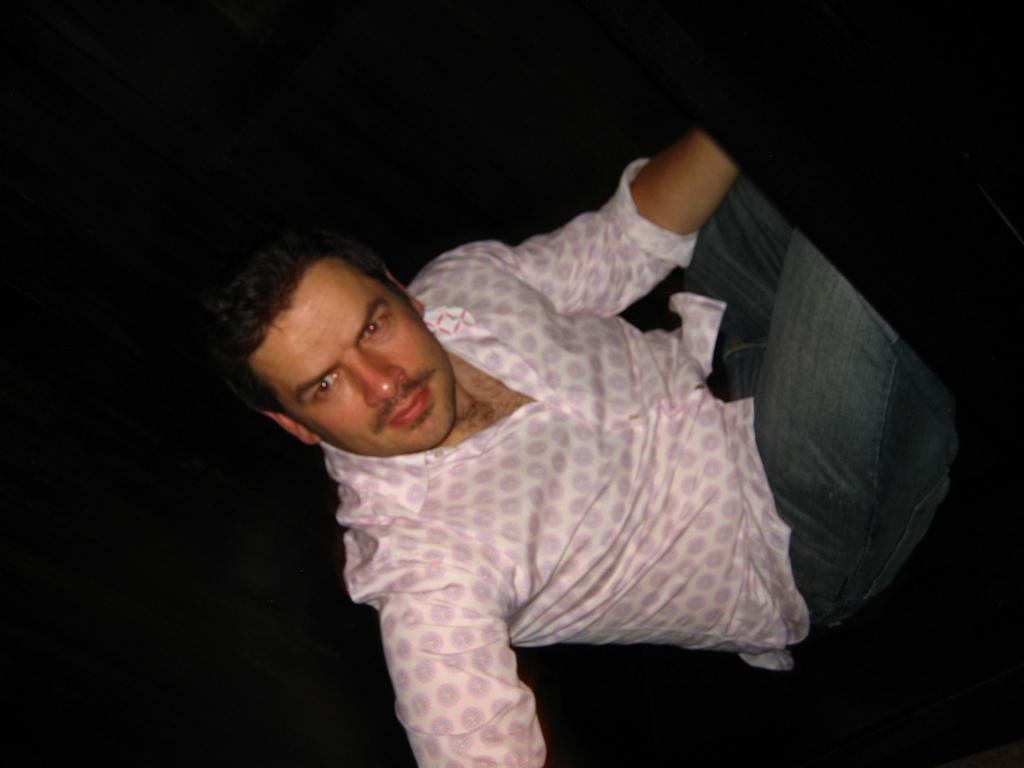What is the main subject of the image? There is a person in the image. What is the person doing in the image? The person is sitting. Can you describe the person's facial expression in the image? The person is making an expression on their face. What type of wood can be seen in the image? There is no wood present in the image; it features a person sitting and making an expression on their face. How does the person control their emotions in the image? The image does not provide information about how the person controls their emotions; it only shows their facial expression. 